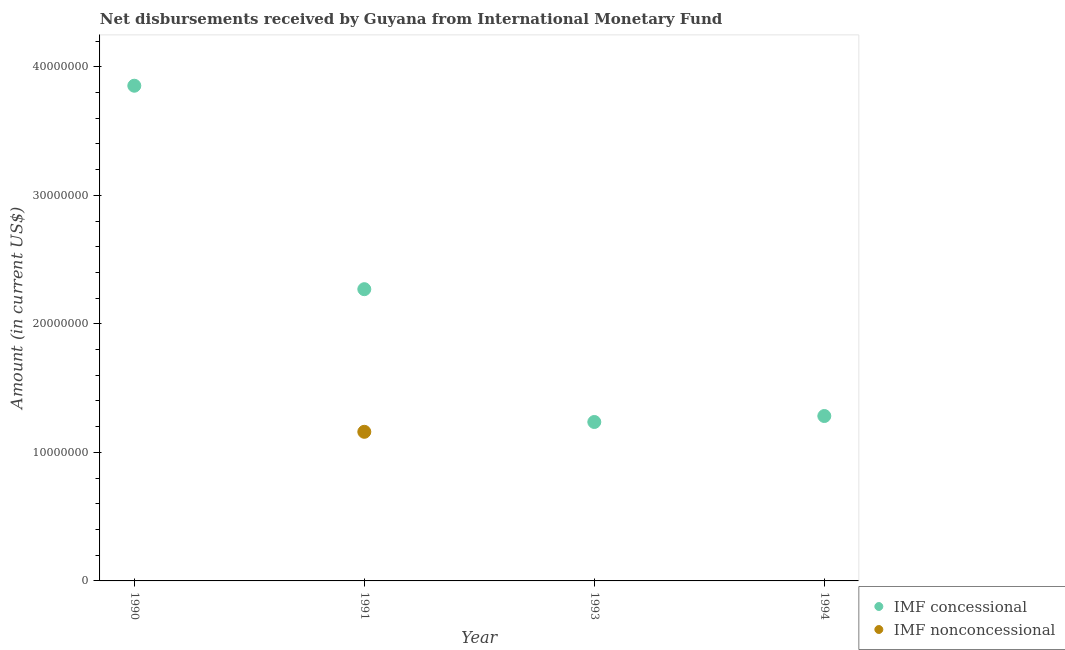Is the number of dotlines equal to the number of legend labels?
Offer a terse response. No. What is the net concessional disbursements from imf in 1994?
Keep it short and to the point. 1.28e+07. Across all years, what is the maximum net non concessional disbursements from imf?
Ensure brevity in your answer.  1.16e+07. Across all years, what is the minimum net concessional disbursements from imf?
Your response must be concise. 1.24e+07. What is the total net concessional disbursements from imf in the graph?
Make the answer very short. 8.64e+07. What is the difference between the net concessional disbursements from imf in 1990 and that in 1991?
Keep it short and to the point. 1.58e+07. What is the difference between the net non concessional disbursements from imf in 1990 and the net concessional disbursements from imf in 1993?
Provide a succinct answer. -1.24e+07. What is the average net concessional disbursements from imf per year?
Your response must be concise. 2.16e+07. In the year 1991, what is the difference between the net concessional disbursements from imf and net non concessional disbursements from imf?
Offer a very short reply. 1.11e+07. What is the ratio of the net concessional disbursements from imf in 1993 to that in 1994?
Your answer should be very brief. 0.96. What is the difference between the highest and the second highest net concessional disbursements from imf?
Give a very brief answer. 1.58e+07. What is the difference between the highest and the lowest net non concessional disbursements from imf?
Provide a succinct answer. 1.16e+07. In how many years, is the net non concessional disbursements from imf greater than the average net non concessional disbursements from imf taken over all years?
Your answer should be very brief. 1. Is the net non concessional disbursements from imf strictly greater than the net concessional disbursements from imf over the years?
Ensure brevity in your answer.  No. How many years are there in the graph?
Offer a very short reply. 4. Does the graph contain any zero values?
Ensure brevity in your answer.  Yes. Does the graph contain grids?
Keep it short and to the point. No. Where does the legend appear in the graph?
Give a very brief answer. Bottom right. What is the title of the graph?
Offer a very short reply. Net disbursements received by Guyana from International Monetary Fund. Does "Technicians" appear as one of the legend labels in the graph?
Offer a very short reply. No. What is the label or title of the X-axis?
Your answer should be very brief. Year. What is the label or title of the Y-axis?
Offer a terse response. Amount (in current US$). What is the Amount (in current US$) of IMF concessional in 1990?
Keep it short and to the point. 3.85e+07. What is the Amount (in current US$) in IMF concessional in 1991?
Provide a short and direct response. 2.27e+07. What is the Amount (in current US$) of IMF nonconcessional in 1991?
Ensure brevity in your answer.  1.16e+07. What is the Amount (in current US$) of IMF concessional in 1993?
Provide a short and direct response. 1.24e+07. What is the Amount (in current US$) in IMF concessional in 1994?
Your answer should be compact. 1.28e+07. Across all years, what is the maximum Amount (in current US$) in IMF concessional?
Make the answer very short. 3.85e+07. Across all years, what is the maximum Amount (in current US$) in IMF nonconcessional?
Keep it short and to the point. 1.16e+07. Across all years, what is the minimum Amount (in current US$) of IMF concessional?
Give a very brief answer. 1.24e+07. Across all years, what is the minimum Amount (in current US$) in IMF nonconcessional?
Make the answer very short. 0. What is the total Amount (in current US$) in IMF concessional in the graph?
Make the answer very short. 8.64e+07. What is the total Amount (in current US$) of IMF nonconcessional in the graph?
Provide a short and direct response. 1.16e+07. What is the difference between the Amount (in current US$) in IMF concessional in 1990 and that in 1991?
Offer a very short reply. 1.58e+07. What is the difference between the Amount (in current US$) in IMF concessional in 1990 and that in 1993?
Keep it short and to the point. 2.62e+07. What is the difference between the Amount (in current US$) in IMF concessional in 1990 and that in 1994?
Your answer should be very brief. 2.57e+07. What is the difference between the Amount (in current US$) of IMF concessional in 1991 and that in 1993?
Make the answer very short. 1.03e+07. What is the difference between the Amount (in current US$) in IMF concessional in 1991 and that in 1994?
Provide a short and direct response. 9.87e+06. What is the difference between the Amount (in current US$) in IMF concessional in 1993 and that in 1994?
Provide a succinct answer. -4.65e+05. What is the difference between the Amount (in current US$) in IMF concessional in 1990 and the Amount (in current US$) in IMF nonconcessional in 1991?
Provide a succinct answer. 2.69e+07. What is the average Amount (in current US$) in IMF concessional per year?
Offer a very short reply. 2.16e+07. What is the average Amount (in current US$) of IMF nonconcessional per year?
Your answer should be very brief. 2.90e+06. In the year 1991, what is the difference between the Amount (in current US$) of IMF concessional and Amount (in current US$) of IMF nonconcessional?
Provide a succinct answer. 1.11e+07. What is the ratio of the Amount (in current US$) of IMF concessional in 1990 to that in 1991?
Give a very brief answer. 1.7. What is the ratio of the Amount (in current US$) in IMF concessional in 1990 to that in 1993?
Ensure brevity in your answer.  3.12. What is the ratio of the Amount (in current US$) of IMF concessional in 1990 to that in 1994?
Your answer should be very brief. 3. What is the ratio of the Amount (in current US$) in IMF concessional in 1991 to that in 1993?
Keep it short and to the point. 1.84. What is the ratio of the Amount (in current US$) in IMF concessional in 1991 to that in 1994?
Ensure brevity in your answer.  1.77. What is the ratio of the Amount (in current US$) in IMF concessional in 1993 to that in 1994?
Ensure brevity in your answer.  0.96. What is the difference between the highest and the second highest Amount (in current US$) of IMF concessional?
Your response must be concise. 1.58e+07. What is the difference between the highest and the lowest Amount (in current US$) in IMF concessional?
Give a very brief answer. 2.62e+07. What is the difference between the highest and the lowest Amount (in current US$) of IMF nonconcessional?
Give a very brief answer. 1.16e+07. 